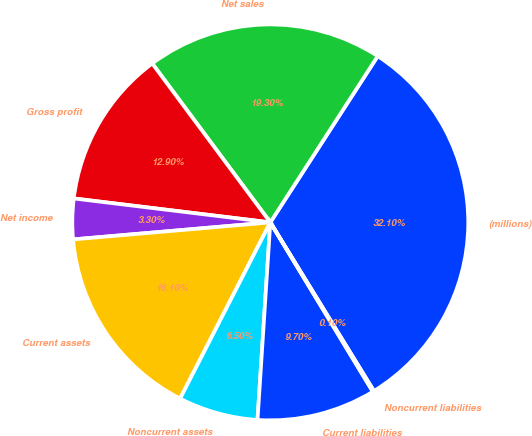Convert chart to OTSL. <chart><loc_0><loc_0><loc_500><loc_500><pie_chart><fcel>(millions)<fcel>Net sales<fcel>Gross profit<fcel>Net income<fcel>Current assets<fcel>Noncurrent assets<fcel>Current liabilities<fcel>Noncurrent liabilities<nl><fcel>32.1%<fcel>19.3%<fcel>12.9%<fcel>3.3%<fcel>16.1%<fcel>6.5%<fcel>9.7%<fcel>0.1%<nl></chart> 